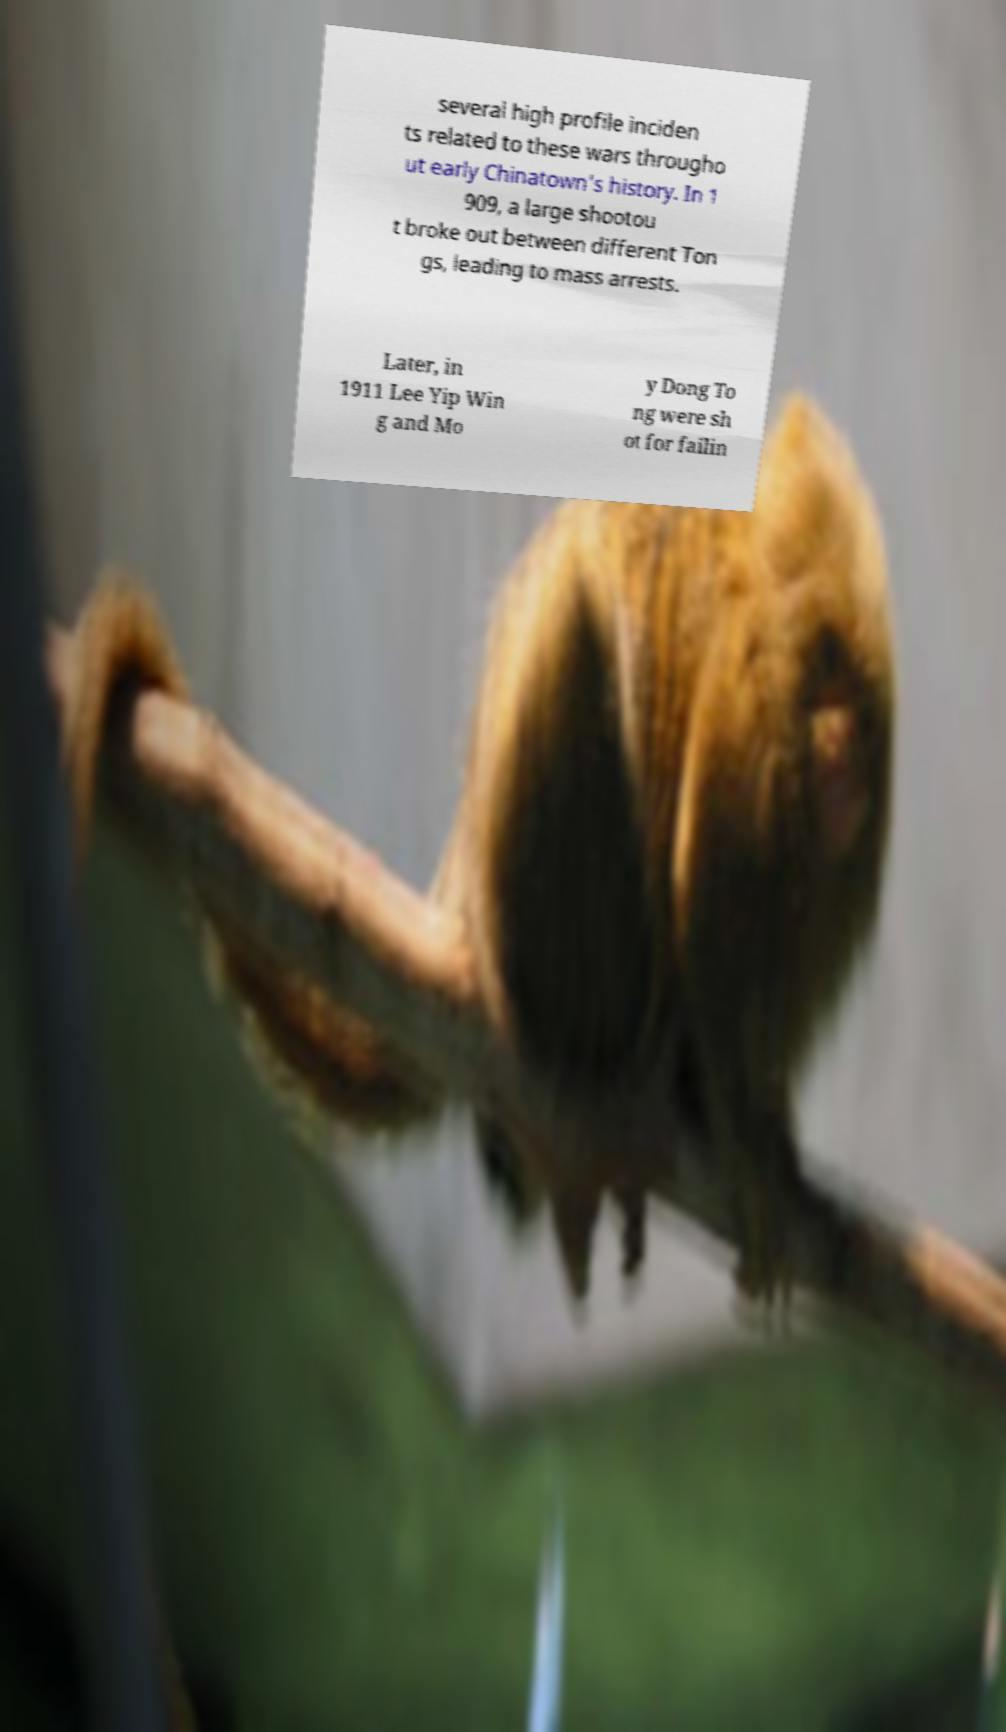Could you extract and type out the text from this image? several high profile inciden ts related to these wars througho ut early Chinatown’s history. In 1 909, a large shootou t broke out between different Ton gs, leading to mass arrests. Later, in 1911 Lee Yip Win g and Mo y Dong To ng were sh ot for failin 